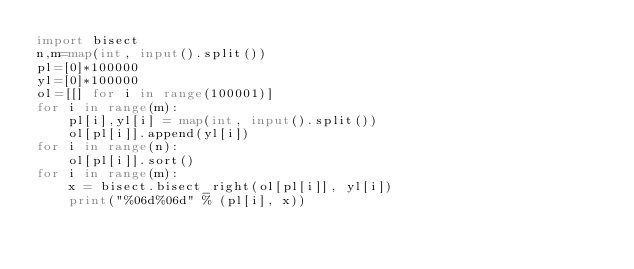Convert code to text. <code><loc_0><loc_0><loc_500><loc_500><_Python_>import bisect
n,m=map(int, input().split())
pl=[0]*100000
yl=[0]*100000
ol=[[] for i in range(100001)]
for i in range(m):
    pl[i],yl[i] = map(int, input().split())
    ol[pl[i]].append(yl[i])
for i in range(n):
    ol[pl[i]].sort()
for i in range(m):
    x = bisect.bisect_right(ol[pl[i]], yl[i])
    print("%06d%06d" % (pl[i], x))
</code> 